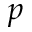<formula> <loc_0><loc_0><loc_500><loc_500>p</formula> 